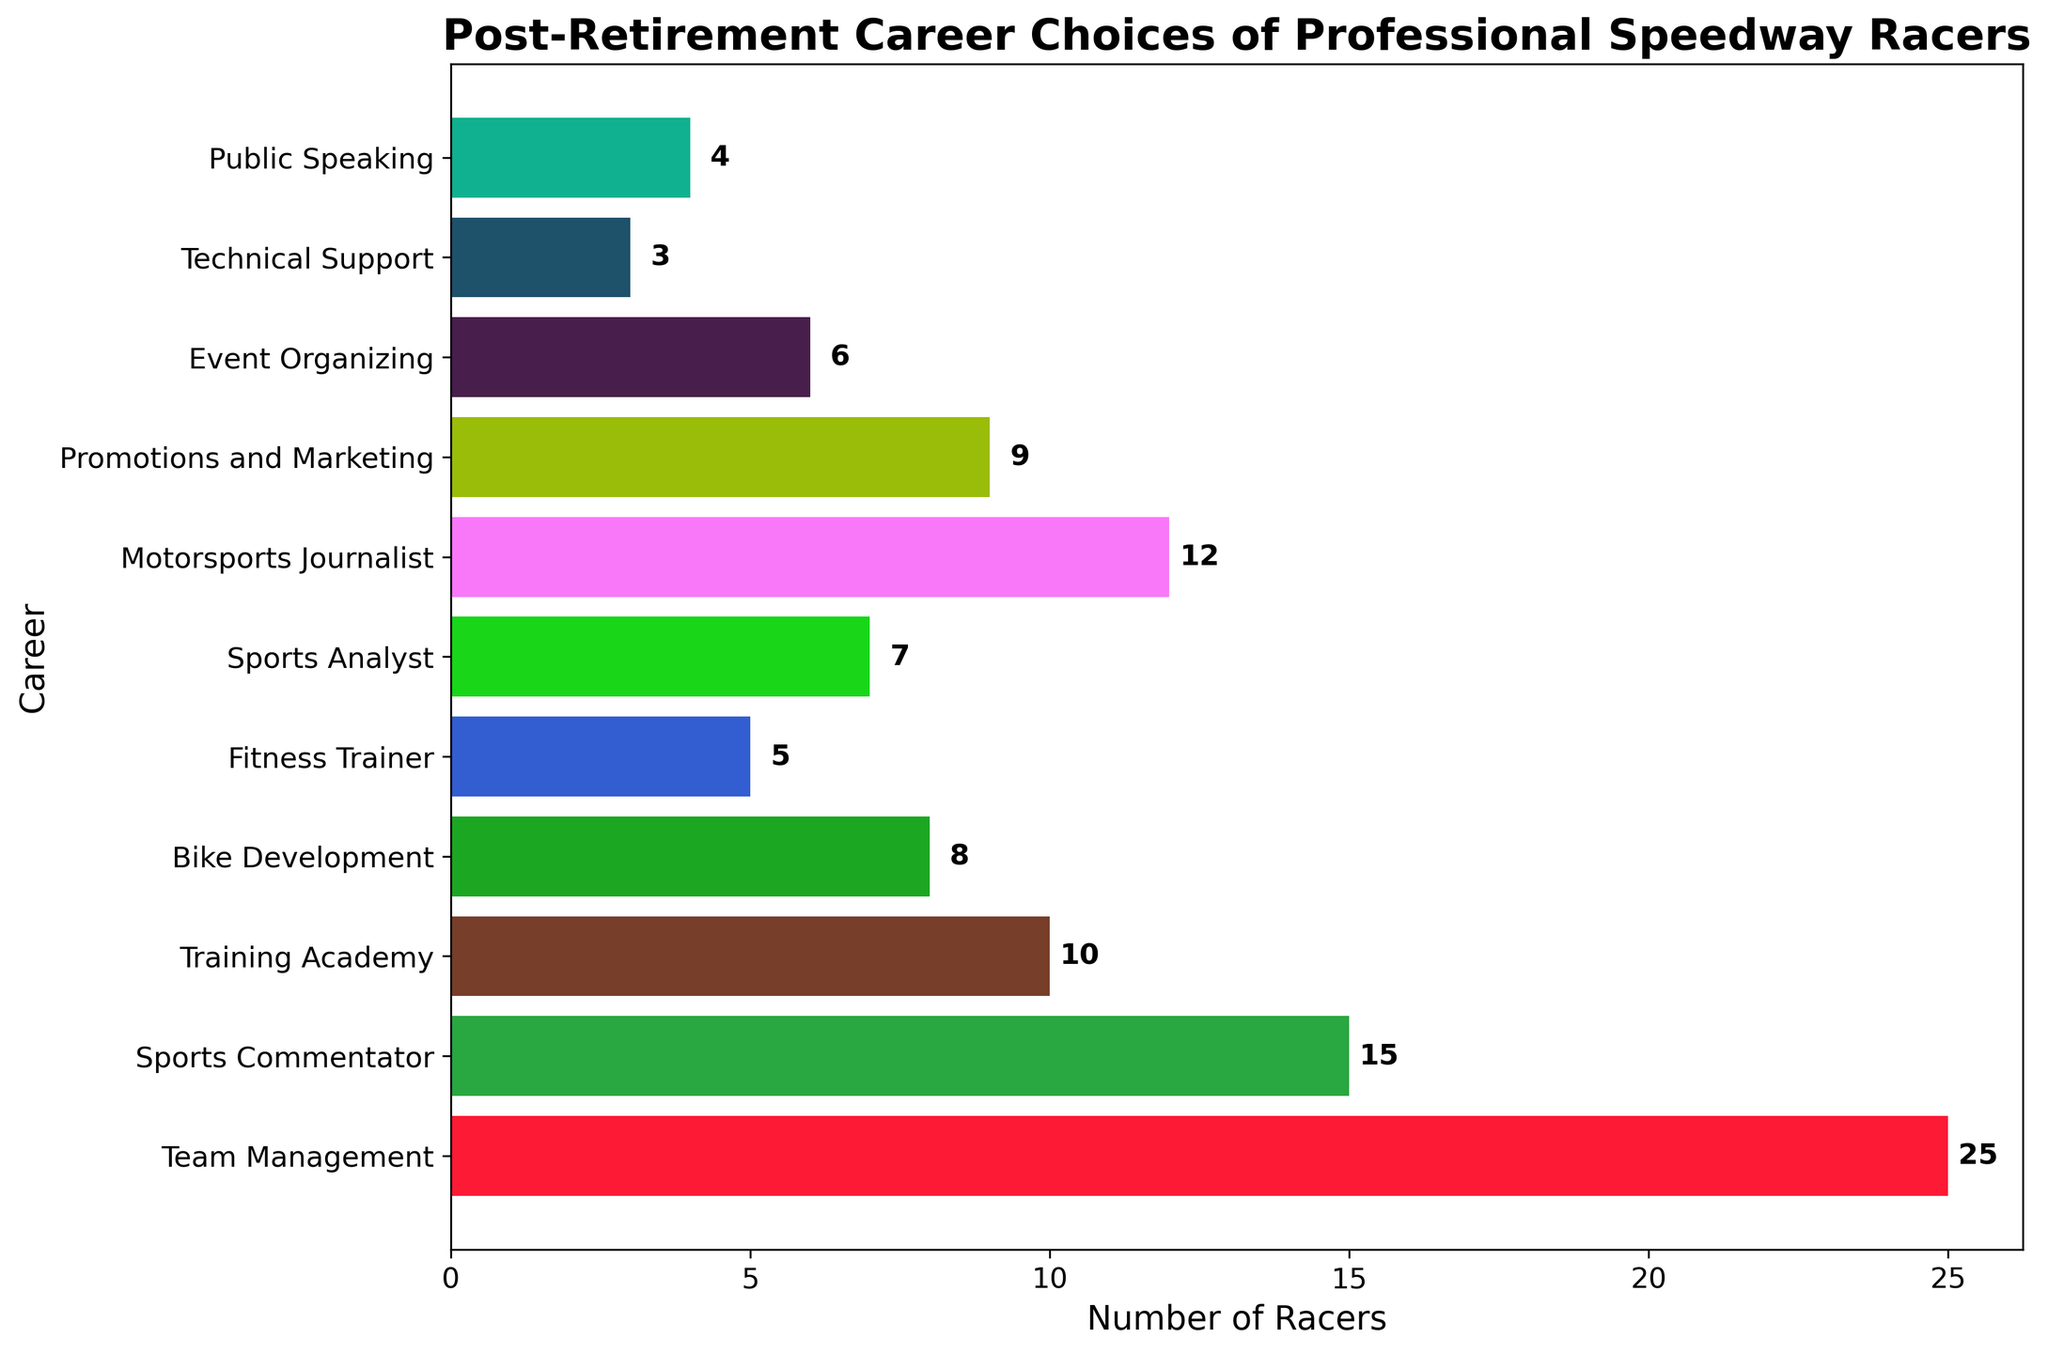Which career choice has the highest number of retired speedway racers? The bar representing "Team Management" is the longest, indicating it has the highest number of retired speedway racers at 25.
Answer: Team Management What is the total number of retired speedway racers working as Sports Commentator and Motorsports Journalist? The number of racers is 15 for Sports Commentator and 12 for Motorsports Journalist. Adding them gives 15 + 12 = 27.
Answer: 27 Which career choice has the least number of retired speedway racers? The bar representing "Technical Support" is the shortest, indicating it has the least number of retired speedway racers at 3.
Answer: Technical Support How many more retired speedway racers chose Team Management over Training Academy? Team Management has 25 racers and Training Academy has 10. The difference is 25 - 10 = 15.
Answer: 15 How many retired speedway racers are involved in either Event Organizing or Public Speaking careers? The number of racers for Event Organizing is 6 and for Public Speaking is 4. Adding them gives 6 + 4 = 10.
Answer: 10 Which career choice is more popular: Promotions and Marketing or Bike Development? Promotions and Marketing has 9 racers whereas Bike Development has 8. Therefore, Promotions and Marketing is more popular.
Answer: Promotions and Marketing What is the combined total of retired speedway racers in all careers related to media (Sports Commentator, Motorsports Journalist, Sports Analyst)? The numbers are 15 for Sports Commentator, 12 for Motorsports Journalist, and 7 for Sports Analyst. Adding them gives 15 + 12 + 7 = 34.
Answer: 34 Is the number of retired speedway racers in Fitness Trainer less than half of those in Team Management? Team Management has 25 racers, half of which is 12.5. The number of racers in Fitness Trainer is 5, which is less than 12.5.
Answer: Yes What is the difference between the number of retired speedway racers in Promotions and Marketing and Public Speaking? Promotions and Marketing has 9 racers while Public Speaking has 4. The difference is 9 - 4 = 5.
Answer: 5 Which career fields have exactly 1 digit representing the number of retired speedway racers? Careers with 1 digit in the number are Training Academy (10), Bike Development (8), Fitness Trainer (5), Sports Analyst (7), Motorsports Journalist (12), Promotions and Marketing (9), Event Organizing (6), Technical Support (3), and Public Speaking (4).
Answer: Training Academy, Bike Development, Fitness Trainer, Sports Analyst, Motorsports Journalist, Promotions and Marketing, Event Organizing, Technical Support, Public Speaking 